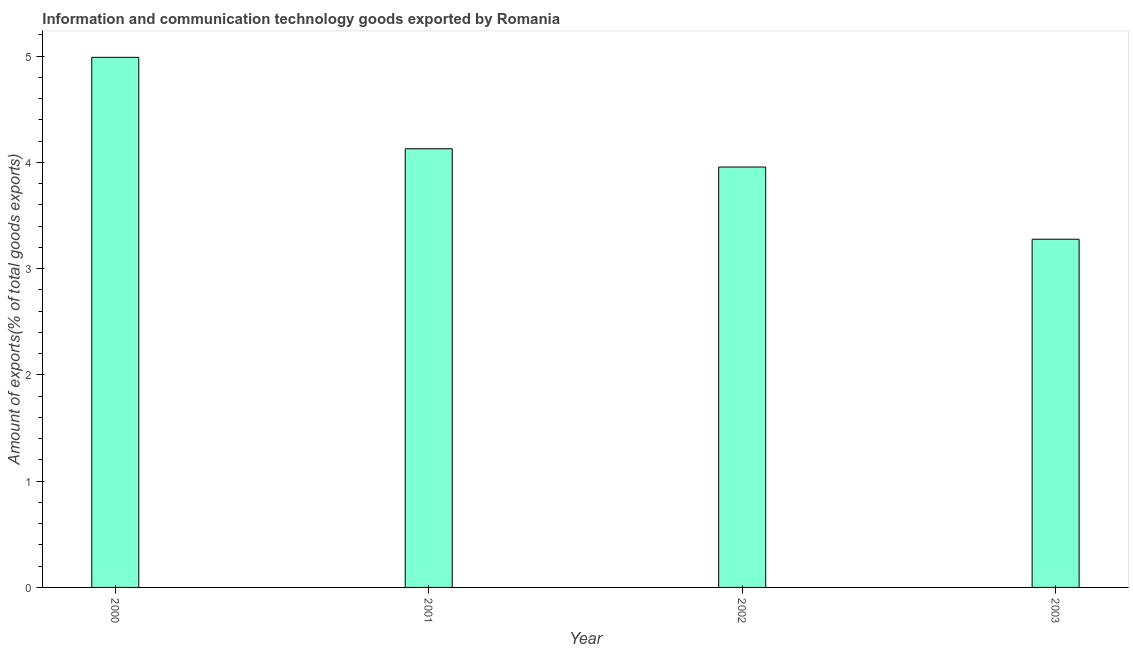What is the title of the graph?
Give a very brief answer. Information and communication technology goods exported by Romania. What is the label or title of the Y-axis?
Provide a succinct answer. Amount of exports(% of total goods exports). What is the amount of ict goods exports in 2002?
Provide a succinct answer. 3.96. Across all years, what is the maximum amount of ict goods exports?
Your answer should be compact. 4.99. Across all years, what is the minimum amount of ict goods exports?
Ensure brevity in your answer.  3.28. In which year was the amount of ict goods exports minimum?
Ensure brevity in your answer.  2003. What is the sum of the amount of ict goods exports?
Your response must be concise. 16.35. What is the difference between the amount of ict goods exports in 2002 and 2003?
Ensure brevity in your answer.  0.68. What is the average amount of ict goods exports per year?
Provide a short and direct response. 4.09. What is the median amount of ict goods exports?
Your answer should be compact. 4.04. Do a majority of the years between 2002 and 2000 (inclusive) have amount of ict goods exports greater than 1.6 %?
Your answer should be very brief. Yes. What is the ratio of the amount of ict goods exports in 2001 to that in 2002?
Keep it short and to the point. 1.04. Is the difference between the amount of ict goods exports in 2000 and 2003 greater than the difference between any two years?
Your answer should be very brief. Yes. What is the difference between the highest and the second highest amount of ict goods exports?
Provide a short and direct response. 0.86. Is the sum of the amount of ict goods exports in 2002 and 2003 greater than the maximum amount of ict goods exports across all years?
Keep it short and to the point. Yes. What is the difference between the highest and the lowest amount of ict goods exports?
Your answer should be very brief. 1.71. How many bars are there?
Your response must be concise. 4. Are all the bars in the graph horizontal?
Provide a short and direct response. No. How many years are there in the graph?
Keep it short and to the point. 4. Are the values on the major ticks of Y-axis written in scientific E-notation?
Ensure brevity in your answer.  No. What is the Amount of exports(% of total goods exports) in 2000?
Keep it short and to the point. 4.99. What is the Amount of exports(% of total goods exports) in 2001?
Offer a very short reply. 4.13. What is the Amount of exports(% of total goods exports) in 2002?
Your answer should be compact. 3.96. What is the Amount of exports(% of total goods exports) in 2003?
Your response must be concise. 3.28. What is the difference between the Amount of exports(% of total goods exports) in 2000 and 2001?
Offer a terse response. 0.86. What is the difference between the Amount of exports(% of total goods exports) in 2000 and 2002?
Keep it short and to the point. 1.03. What is the difference between the Amount of exports(% of total goods exports) in 2000 and 2003?
Your answer should be very brief. 1.71. What is the difference between the Amount of exports(% of total goods exports) in 2001 and 2002?
Ensure brevity in your answer.  0.17. What is the difference between the Amount of exports(% of total goods exports) in 2001 and 2003?
Provide a succinct answer. 0.85. What is the difference between the Amount of exports(% of total goods exports) in 2002 and 2003?
Your answer should be very brief. 0.68. What is the ratio of the Amount of exports(% of total goods exports) in 2000 to that in 2001?
Make the answer very short. 1.21. What is the ratio of the Amount of exports(% of total goods exports) in 2000 to that in 2002?
Provide a succinct answer. 1.26. What is the ratio of the Amount of exports(% of total goods exports) in 2000 to that in 2003?
Provide a succinct answer. 1.52. What is the ratio of the Amount of exports(% of total goods exports) in 2001 to that in 2002?
Offer a very short reply. 1.04. What is the ratio of the Amount of exports(% of total goods exports) in 2001 to that in 2003?
Ensure brevity in your answer.  1.26. What is the ratio of the Amount of exports(% of total goods exports) in 2002 to that in 2003?
Offer a very short reply. 1.21. 